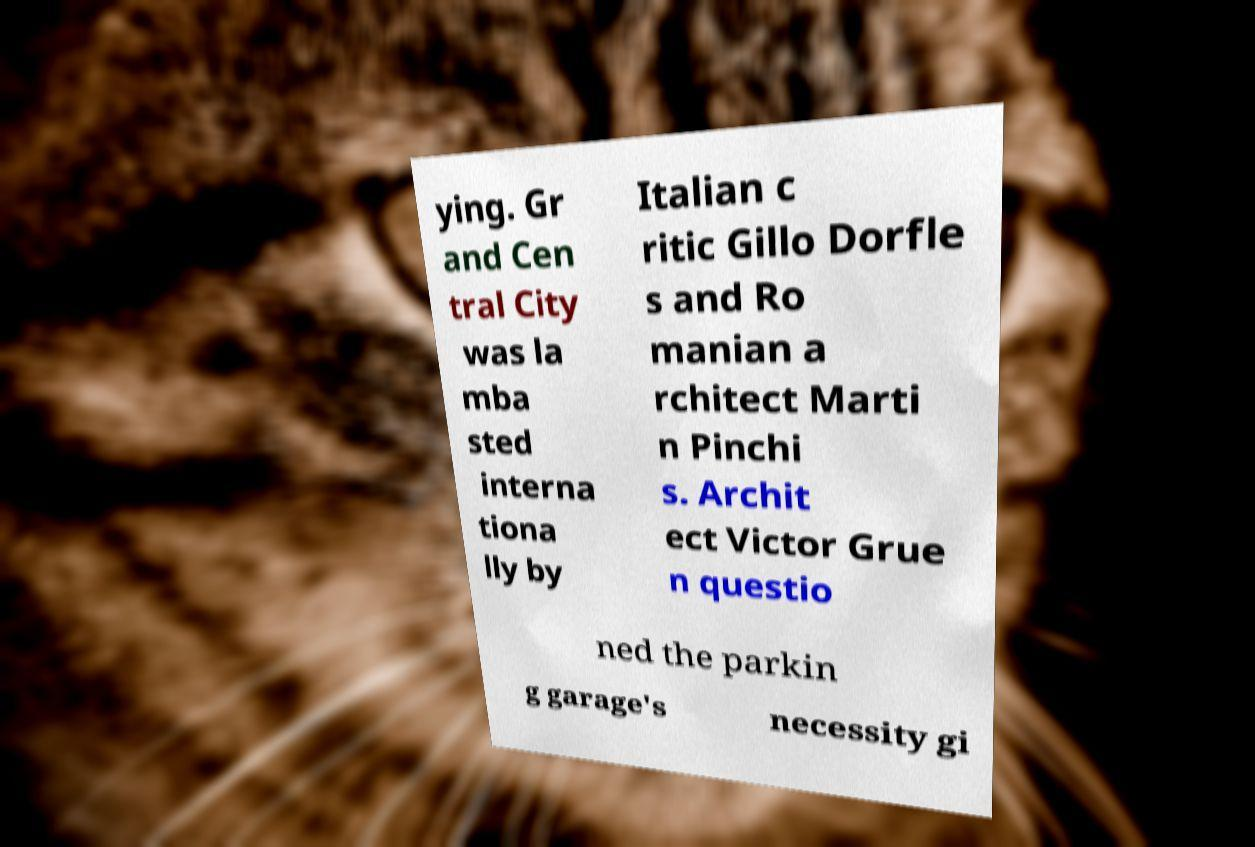Can you read and provide the text displayed in the image?This photo seems to have some interesting text. Can you extract and type it out for me? ying. Gr and Cen tral City was la mba sted interna tiona lly by Italian c ritic Gillo Dorfle s and Ro manian a rchitect Marti n Pinchi s. Archit ect Victor Grue n questio ned the parkin g garage's necessity gi 